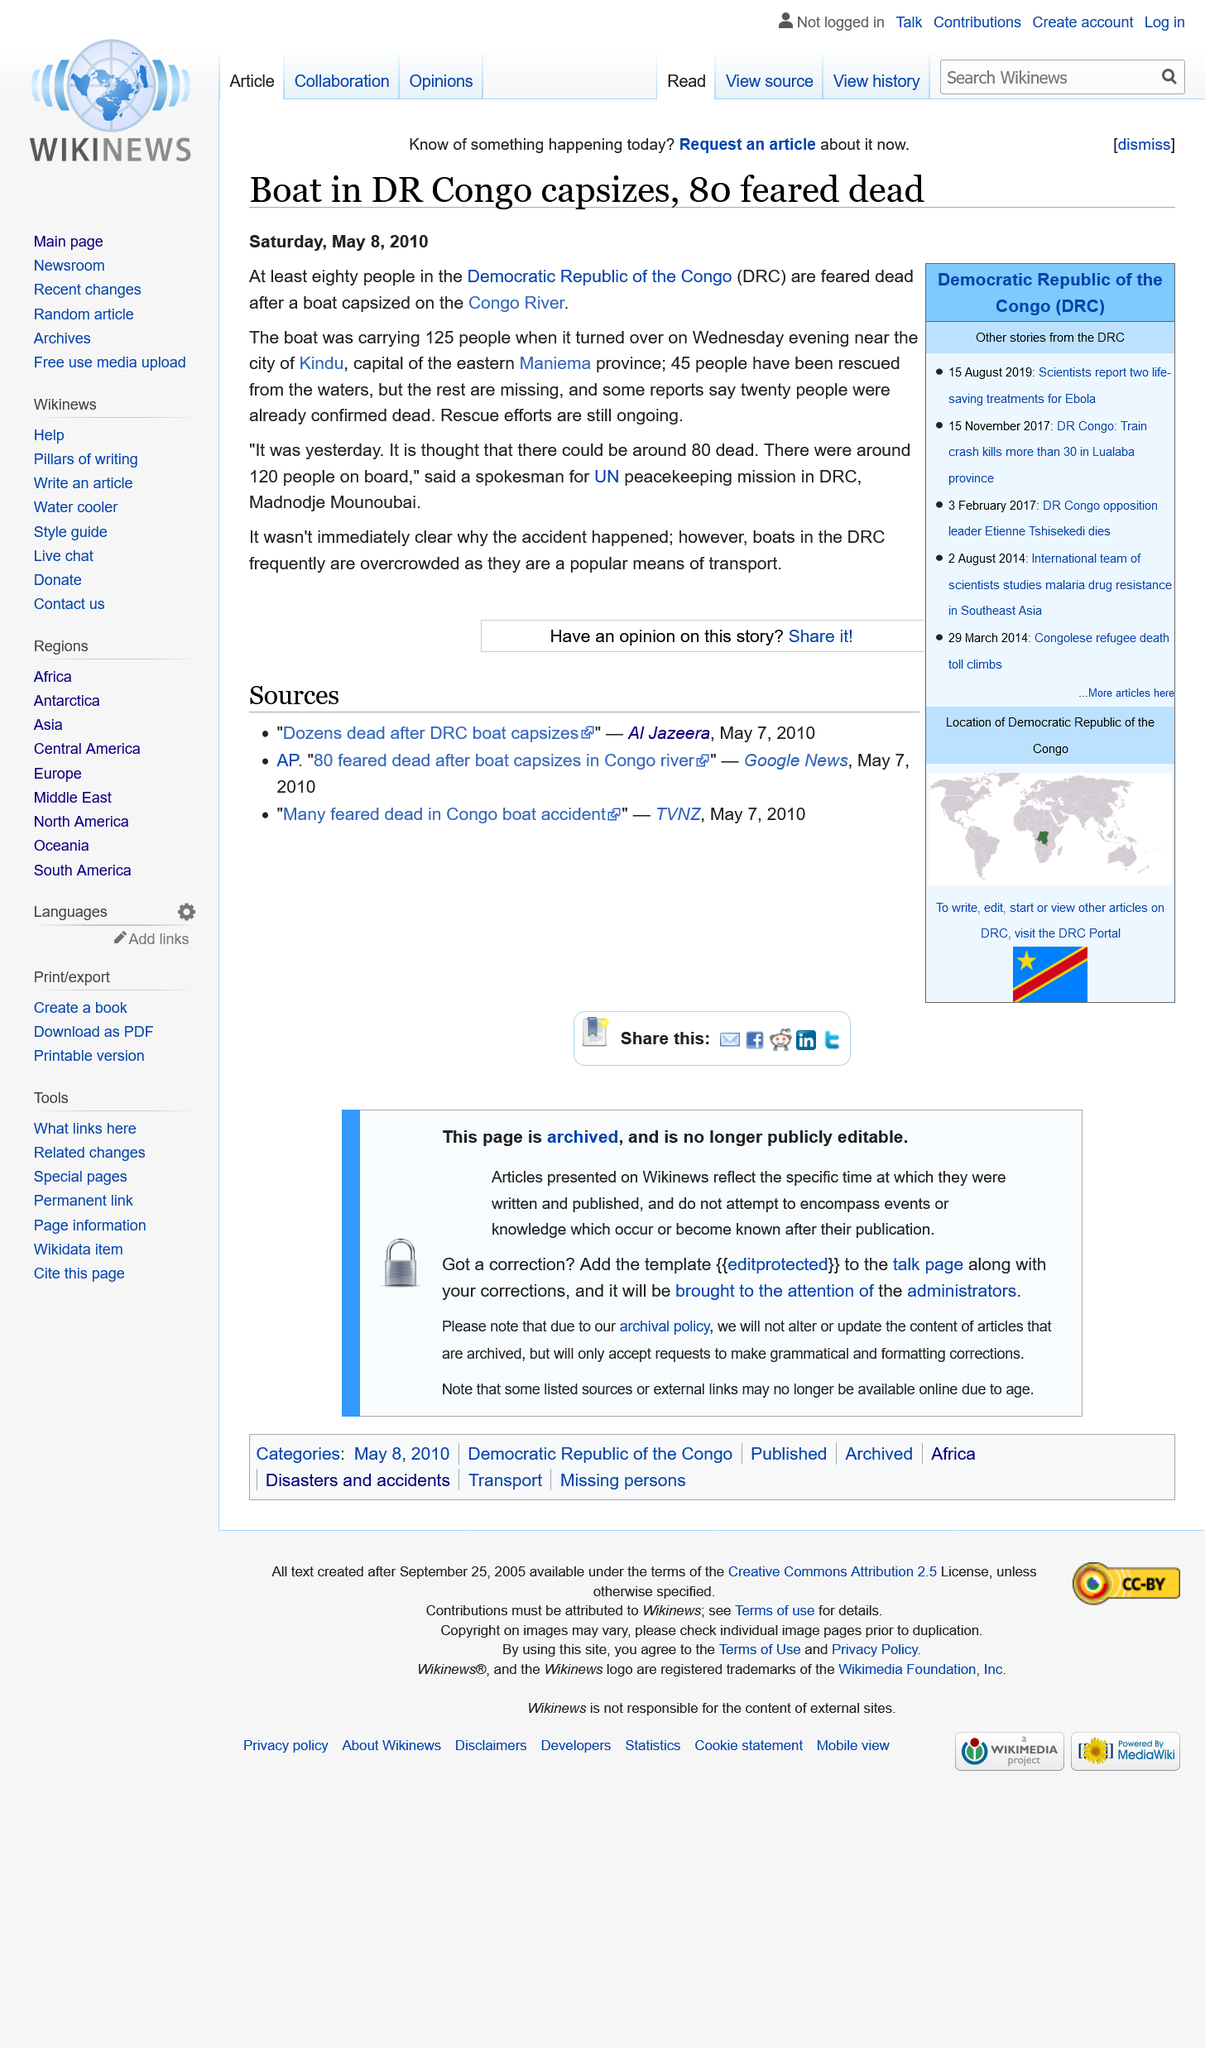Highlight a few significant elements in this photo. The boat capsized in the Democratic Republic of Congo. Boats in the Democratic Republic of the Congo (DRC) are frequently overcrowded due to their popularity as a mode of transportation. On Wednesday evening, the boat capsized. 